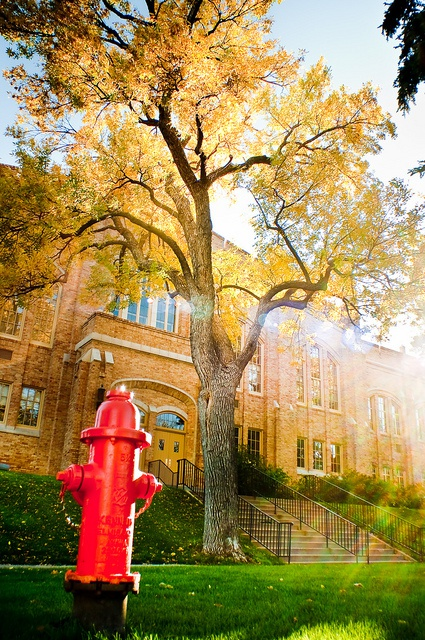Describe the objects in this image and their specific colors. I can see a fire hydrant in teal, red, black, and salmon tones in this image. 